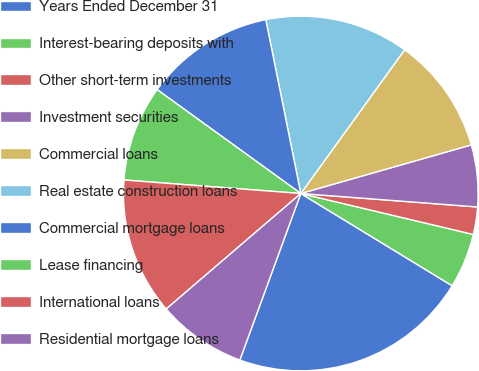Convert chart to OTSL. <chart><loc_0><loc_0><loc_500><loc_500><pie_chart><fcel>Years Ended December 31<fcel>Interest-bearing deposits with<fcel>Other short-term investments<fcel>Investment securities<fcel>Commercial loans<fcel>Real estate construction loans<fcel>Commercial mortgage loans<fcel>Lease financing<fcel>International loans<fcel>Residential mortgage loans<nl><fcel>21.87%<fcel>5.0%<fcel>2.5%<fcel>5.63%<fcel>10.62%<fcel>13.12%<fcel>11.87%<fcel>8.75%<fcel>12.5%<fcel>8.13%<nl></chart> 